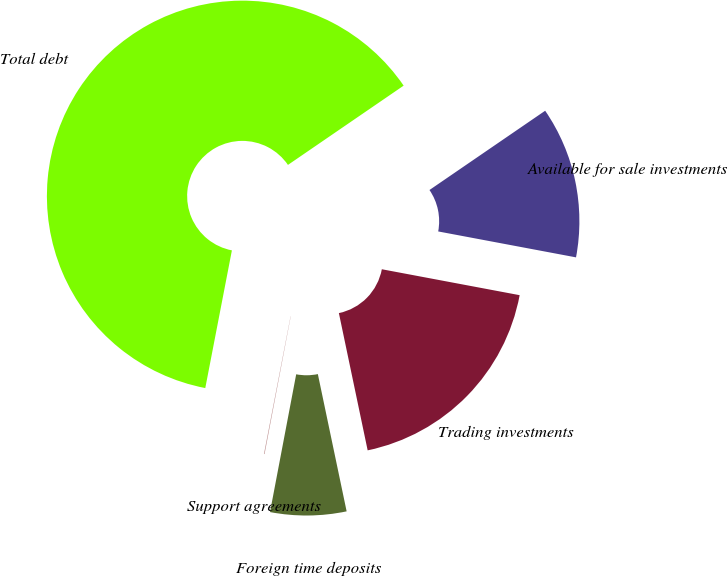Convert chart. <chart><loc_0><loc_0><loc_500><loc_500><pie_chart><fcel>Available for sale investments<fcel>Trading investments<fcel>Foreign time deposits<fcel>Support agreements<fcel>Total debt<nl><fcel>12.52%<fcel>18.75%<fcel>6.28%<fcel>0.05%<fcel>62.4%<nl></chart> 